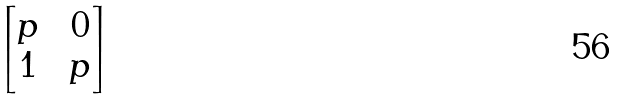<formula> <loc_0><loc_0><loc_500><loc_500>\begin{bmatrix} p \, & \, 0 \\ 1 \, & \, p \end{bmatrix}</formula> 